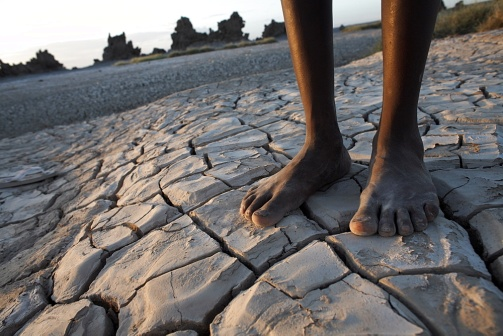What are the key elements in this picture?
 The image captures a scene of stark contrast and desolation. At the center of the frame, a pair of bare feet, dark in complexion, stand firmly on the cracked and parched ground. The ground itself is a dull gray, riddled with a network of cracks and crevices that speak of intense dryness and heat.

In the distance, the horizon is marked by a sparse scattering of trees and shrubs, their presence a testament to life's resilience in harsh conditions. Above them, the sky is a pale blue, its tranquility undisturbed except for the setting sun. The sun, though not directly visible in the image, casts a warm, orange glow that subtly illuminates the scene, hinting at the end of another day in this arid landscape. 

Despite the absence of any discernible action or movement, the image conveys a sense of quiet endurance, as if the feet and the ground they stand on are locked in a silent dialogue of survival and resilience. There is no text or other objects present in the image. The relative positions of the objects remain constant, with the feet centrally located, the ground beneath, and the horizon in the distance. The sun's glow is diffused evenly across the scene, suggesting it is located directly above or slightly to one side, out of the frame. 